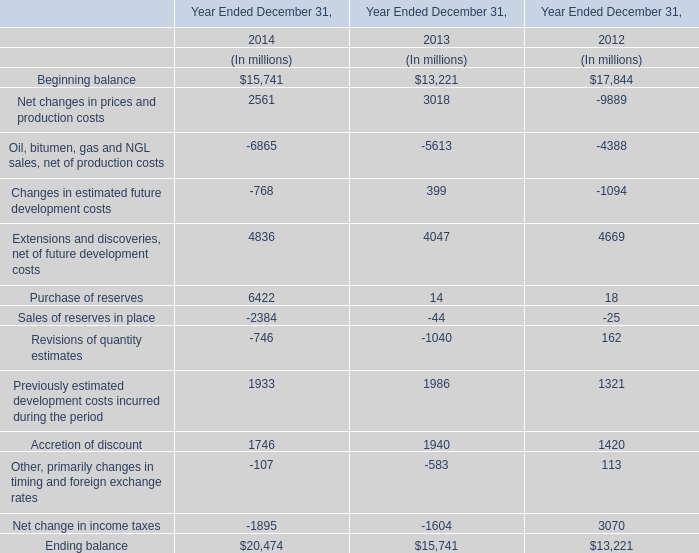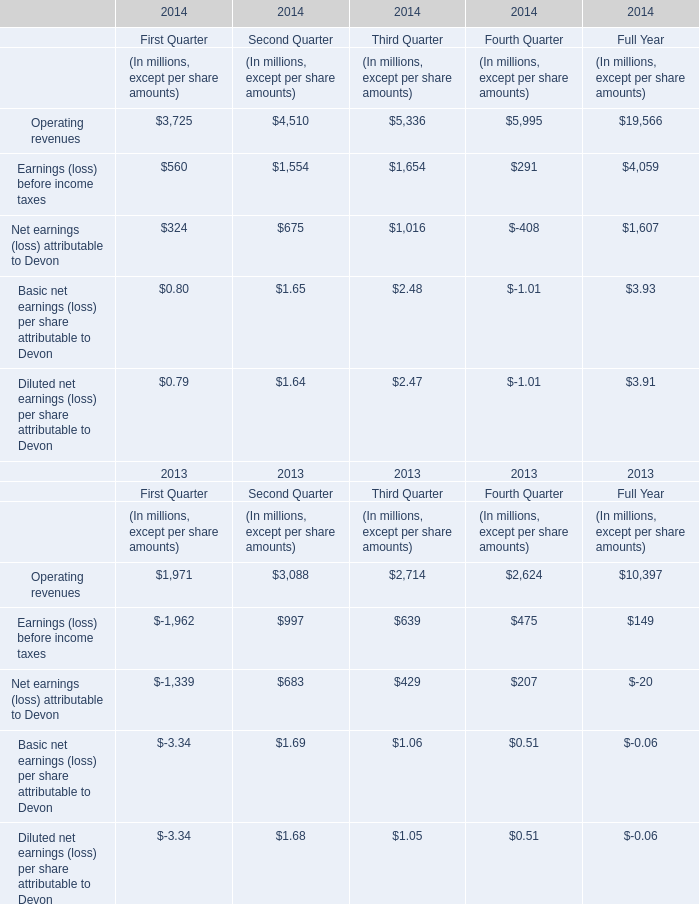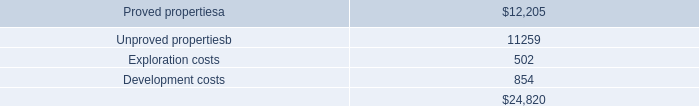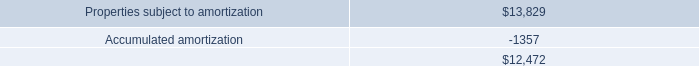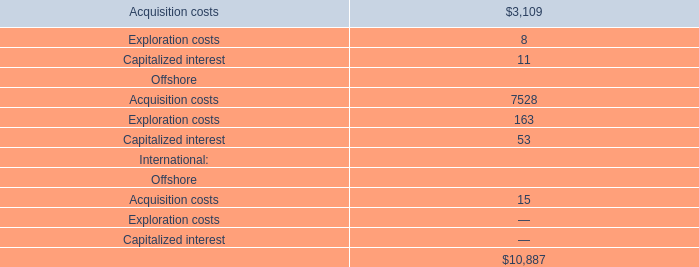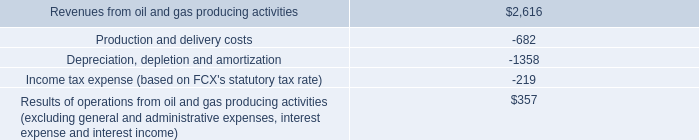What is the average growth rate of Beginning balance between 2013 and 2014? 
Computations: ((15741 - 13221) / 13221)
Answer: 0.19061. 